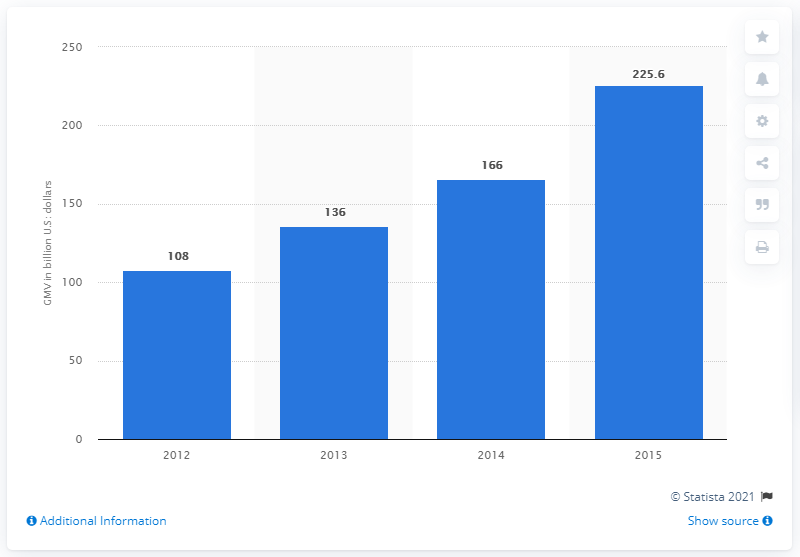Give some essential details in this illustration. Amazon's GMV in the previous year was 166... In 2015, Amazon's Gross Merchandise Volume (GMV) was 225.6 billion dollars. 